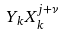<formula> <loc_0><loc_0><loc_500><loc_500>Y _ { k } X _ { k } ^ { j + \nu }</formula> 